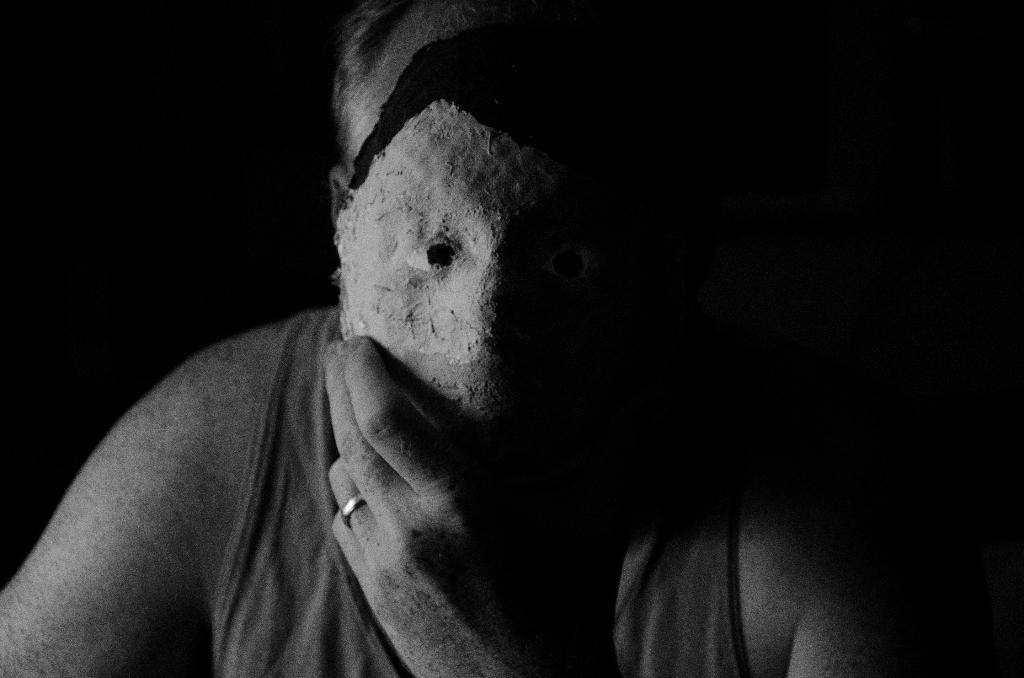What is the main subject of the image? There is a person in the image. What is the person holding in his hand? The person is holding a mask in his hand. What is the person doing with the mask? The person has placed the mask in front of his face. Where is the playground located in the image? There is no playground present in the image. Is the person in the image sleeping? The person in the image is not sleeping; he is holding a mask in his hand and placing it in front of his face. Can you see the person's grandmother in the image? There is no mention of a grandmother in the image, and no one else is visible besides the person holding the mask. 